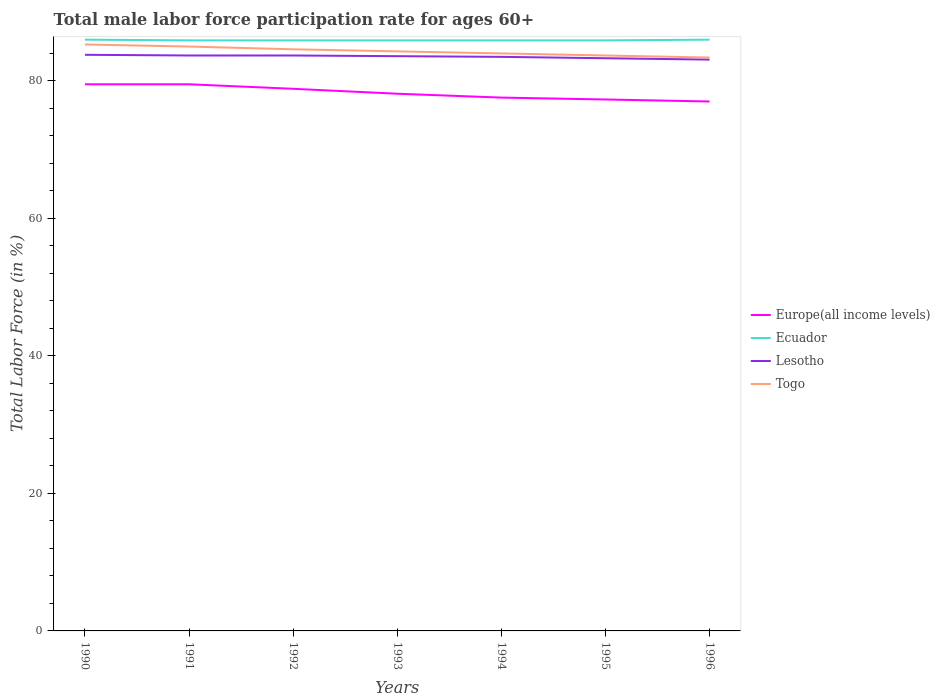Does the line corresponding to Europe(all income levels) intersect with the line corresponding to Lesotho?
Your response must be concise. No. Is the number of lines equal to the number of legend labels?
Keep it short and to the point. Yes. Across all years, what is the maximum male labor force participation rate in Lesotho?
Give a very brief answer. 83.1. What is the total male labor force participation rate in Europe(all income levels) in the graph?
Provide a succinct answer. 2.21. What is the difference between the highest and the second highest male labor force participation rate in Europe(all income levels)?
Provide a succinct answer. 2.5. What is the difference between the highest and the lowest male labor force participation rate in Europe(all income levels)?
Make the answer very short. 3. How many lines are there?
Offer a very short reply. 4. How many years are there in the graph?
Provide a succinct answer. 7. What is the difference between two consecutive major ticks on the Y-axis?
Provide a short and direct response. 20. Does the graph contain any zero values?
Offer a terse response. No. How many legend labels are there?
Give a very brief answer. 4. What is the title of the graph?
Provide a short and direct response. Total male labor force participation rate for ages 60+. Does "Qatar" appear as one of the legend labels in the graph?
Your answer should be very brief. No. What is the label or title of the X-axis?
Keep it short and to the point. Years. What is the label or title of the Y-axis?
Your answer should be compact. Total Labor Force (in %). What is the Total Labor Force (in %) in Europe(all income levels) in 1990?
Your response must be concise. 79.51. What is the Total Labor Force (in %) in Lesotho in 1990?
Ensure brevity in your answer.  83.8. What is the Total Labor Force (in %) in Togo in 1990?
Make the answer very short. 85.3. What is the Total Labor Force (in %) of Europe(all income levels) in 1991?
Give a very brief answer. 79.51. What is the Total Labor Force (in %) in Ecuador in 1991?
Provide a short and direct response. 85.9. What is the Total Labor Force (in %) of Lesotho in 1991?
Offer a very short reply. 83.7. What is the Total Labor Force (in %) in Europe(all income levels) in 1992?
Give a very brief answer. 78.85. What is the Total Labor Force (in %) of Ecuador in 1992?
Offer a very short reply. 85.9. What is the Total Labor Force (in %) of Lesotho in 1992?
Your answer should be compact. 83.7. What is the Total Labor Force (in %) in Togo in 1992?
Offer a very short reply. 84.6. What is the Total Labor Force (in %) in Europe(all income levels) in 1993?
Keep it short and to the point. 78.14. What is the Total Labor Force (in %) of Ecuador in 1993?
Your answer should be compact. 85.9. What is the Total Labor Force (in %) in Lesotho in 1993?
Your answer should be compact. 83.6. What is the Total Labor Force (in %) in Togo in 1993?
Ensure brevity in your answer.  84.3. What is the Total Labor Force (in %) of Europe(all income levels) in 1994?
Give a very brief answer. 77.57. What is the Total Labor Force (in %) of Ecuador in 1994?
Give a very brief answer. 85.9. What is the Total Labor Force (in %) in Lesotho in 1994?
Provide a succinct answer. 83.5. What is the Total Labor Force (in %) of Togo in 1994?
Your answer should be compact. 84. What is the Total Labor Force (in %) in Europe(all income levels) in 1995?
Your answer should be very brief. 77.3. What is the Total Labor Force (in %) in Ecuador in 1995?
Your answer should be compact. 85.9. What is the Total Labor Force (in %) in Lesotho in 1995?
Ensure brevity in your answer.  83.3. What is the Total Labor Force (in %) of Togo in 1995?
Make the answer very short. 83.7. What is the Total Labor Force (in %) in Europe(all income levels) in 1996?
Offer a terse response. 77.01. What is the Total Labor Force (in %) of Ecuador in 1996?
Offer a terse response. 86. What is the Total Labor Force (in %) in Lesotho in 1996?
Provide a succinct answer. 83.1. What is the Total Labor Force (in %) in Togo in 1996?
Offer a very short reply. 83.4. Across all years, what is the maximum Total Labor Force (in %) in Europe(all income levels)?
Your answer should be very brief. 79.51. Across all years, what is the maximum Total Labor Force (in %) of Lesotho?
Give a very brief answer. 83.8. Across all years, what is the maximum Total Labor Force (in %) in Togo?
Provide a succinct answer. 85.3. Across all years, what is the minimum Total Labor Force (in %) of Europe(all income levels)?
Offer a terse response. 77.01. Across all years, what is the minimum Total Labor Force (in %) in Ecuador?
Give a very brief answer. 85.9. Across all years, what is the minimum Total Labor Force (in %) in Lesotho?
Offer a very short reply. 83.1. Across all years, what is the minimum Total Labor Force (in %) in Togo?
Your response must be concise. 83.4. What is the total Total Labor Force (in %) in Europe(all income levels) in the graph?
Give a very brief answer. 547.9. What is the total Total Labor Force (in %) in Ecuador in the graph?
Provide a succinct answer. 601.5. What is the total Total Labor Force (in %) of Lesotho in the graph?
Keep it short and to the point. 584.7. What is the total Total Labor Force (in %) in Togo in the graph?
Make the answer very short. 590.3. What is the difference between the Total Labor Force (in %) of Europe(all income levels) in 1990 and that in 1991?
Your answer should be compact. 0. What is the difference between the Total Labor Force (in %) in Lesotho in 1990 and that in 1991?
Give a very brief answer. 0.1. What is the difference between the Total Labor Force (in %) in Europe(all income levels) in 1990 and that in 1992?
Give a very brief answer. 0.66. What is the difference between the Total Labor Force (in %) in Ecuador in 1990 and that in 1992?
Provide a short and direct response. 0.1. What is the difference between the Total Labor Force (in %) in Lesotho in 1990 and that in 1992?
Your answer should be very brief. 0.1. What is the difference between the Total Labor Force (in %) in Europe(all income levels) in 1990 and that in 1993?
Your response must be concise. 1.37. What is the difference between the Total Labor Force (in %) of Ecuador in 1990 and that in 1993?
Ensure brevity in your answer.  0.1. What is the difference between the Total Labor Force (in %) in Lesotho in 1990 and that in 1993?
Offer a terse response. 0.2. What is the difference between the Total Labor Force (in %) in Europe(all income levels) in 1990 and that in 1994?
Provide a short and direct response. 1.94. What is the difference between the Total Labor Force (in %) of Ecuador in 1990 and that in 1994?
Your answer should be very brief. 0.1. What is the difference between the Total Labor Force (in %) of Lesotho in 1990 and that in 1994?
Offer a terse response. 0.3. What is the difference between the Total Labor Force (in %) in Europe(all income levels) in 1990 and that in 1995?
Your response must be concise. 2.21. What is the difference between the Total Labor Force (in %) in Europe(all income levels) in 1990 and that in 1996?
Provide a succinct answer. 2.5. What is the difference between the Total Labor Force (in %) of Ecuador in 1990 and that in 1996?
Offer a very short reply. 0. What is the difference between the Total Labor Force (in %) of Togo in 1990 and that in 1996?
Offer a very short reply. 1.9. What is the difference between the Total Labor Force (in %) in Europe(all income levels) in 1991 and that in 1992?
Offer a terse response. 0.65. What is the difference between the Total Labor Force (in %) of Europe(all income levels) in 1991 and that in 1993?
Give a very brief answer. 1.37. What is the difference between the Total Labor Force (in %) of Ecuador in 1991 and that in 1993?
Your answer should be compact. 0. What is the difference between the Total Labor Force (in %) in Europe(all income levels) in 1991 and that in 1994?
Keep it short and to the point. 1.94. What is the difference between the Total Labor Force (in %) in Lesotho in 1991 and that in 1994?
Provide a succinct answer. 0.2. What is the difference between the Total Labor Force (in %) in Europe(all income levels) in 1991 and that in 1995?
Provide a short and direct response. 2.21. What is the difference between the Total Labor Force (in %) of Europe(all income levels) in 1991 and that in 1996?
Your answer should be very brief. 2.5. What is the difference between the Total Labor Force (in %) in Europe(all income levels) in 1992 and that in 1993?
Provide a succinct answer. 0.72. What is the difference between the Total Labor Force (in %) of Togo in 1992 and that in 1993?
Give a very brief answer. 0.3. What is the difference between the Total Labor Force (in %) in Europe(all income levels) in 1992 and that in 1994?
Ensure brevity in your answer.  1.28. What is the difference between the Total Labor Force (in %) of Lesotho in 1992 and that in 1994?
Give a very brief answer. 0.2. What is the difference between the Total Labor Force (in %) of Europe(all income levels) in 1992 and that in 1995?
Your answer should be compact. 1.56. What is the difference between the Total Labor Force (in %) in Ecuador in 1992 and that in 1995?
Provide a succinct answer. 0. What is the difference between the Total Labor Force (in %) in Lesotho in 1992 and that in 1995?
Provide a succinct answer. 0.4. What is the difference between the Total Labor Force (in %) in Europe(all income levels) in 1992 and that in 1996?
Your response must be concise. 1.85. What is the difference between the Total Labor Force (in %) of Lesotho in 1992 and that in 1996?
Ensure brevity in your answer.  0.6. What is the difference between the Total Labor Force (in %) in Togo in 1992 and that in 1996?
Your answer should be compact. 1.2. What is the difference between the Total Labor Force (in %) in Europe(all income levels) in 1993 and that in 1994?
Offer a very short reply. 0.57. What is the difference between the Total Labor Force (in %) in Lesotho in 1993 and that in 1994?
Make the answer very short. 0.1. What is the difference between the Total Labor Force (in %) of Togo in 1993 and that in 1994?
Your answer should be very brief. 0.3. What is the difference between the Total Labor Force (in %) in Europe(all income levels) in 1993 and that in 1995?
Ensure brevity in your answer.  0.84. What is the difference between the Total Labor Force (in %) of Lesotho in 1993 and that in 1995?
Provide a short and direct response. 0.3. What is the difference between the Total Labor Force (in %) of Europe(all income levels) in 1993 and that in 1996?
Keep it short and to the point. 1.13. What is the difference between the Total Labor Force (in %) in Togo in 1993 and that in 1996?
Provide a short and direct response. 0.9. What is the difference between the Total Labor Force (in %) in Europe(all income levels) in 1994 and that in 1995?
Make the answer very short. 0.28. What is the difference between the Total Labor Force (in %) in Togo in 1994 and that in 1995?
Your answer should be very brief. 0.3. What is the difference between the Total Labor Force (in %) of Europe(all income levels) in 1994 and that in 1996?
Your response must be concise. 0.56. What is the difference between the Total Labor Force (in %) in Lesotho in 1994 and that in 1996?
Keep it short and to the point. 0.4. What is the difference between the Total Labor Force (in %) of Europe(all income levels) in 1995 and that in 1996?
Give a very brief answer. 0.29. What is the difference between the Total Labor Force (in %) of Ecuador in 1995 and that in 1996?
Provide a short and direct response. -0.1. What is the difference between the Total Labor Force (in %) of Lesotho in 1995 and that in 1996?
Your response must be concise. 0.2. What is the difference between the Total Labor Force (in %) in Europe(all income levels) in 1990 and the Total Labor Force (in %) in Ecuador in 1991?
Ensure brevity in your answer.  -6.39. What is the difference between the Total Labor Force (in %) of Europe(all income levels) in 1990 and the Total Labor Force (in %) of Lesotho in 1991?
Your answer should be very brief. -4.19. What is the difference between the Total Labor Force (in %) of Europe(all income levels) in 1990 and the Total Labor Force (in %) of Togo in 1991?
Offer a terse response. -5.49. What is the difference between the Total Labor Force (in %) in Lesotho in 1990 and the Total Labor Force (in %) in Togo in 1991?
Offer a very short reply. -1.2. What is the difference between the Total Labor Force (in %) in Europe(all income levels) in 1990 and the Total Labor Force (in %) in Ecuador in 1992?
Offer a very short reply. -6.39. What is the difference between the Total Labor Force (in %) in Europe(all income levels) in 1990 and the Total Labor Force (in %) in Lesotho in 1992?
Offer a terse response. -4.19. What is the difference between the Total Labor Force (in %) in Europe(all income levels) in 1990 and the Total Labor Force (in %) in Togo in 1992?
Provide a short and direct response. -5.09. What is the difference between the Total Labor Force (in %) of Ecuador in 1990 and the Total Labor Force (in %) of Lesotho in 1992?
Your answer should be very brief. 2.3. What is the difference between the Total Labor Force (in %) in Ecuador in 1990 and the Total Labor Force (in %) in Togo in 1992?
Keep it short and to the point. 1.4. What is the difference between the Total Labor Force (in %) in Europe(all income levels) in 1990 and the Total Labor Force (in %) in Ecuador in 1993?
Keep it short and to the point. -6.39. What is the difference between the Total Labor Force (in %) of Europe(all income levels) in 1990 and the Total Labor Force (in %) of Lesotho in 1993?
Offer a terse response. -4.09. What is the difference between the Total Labor Force (in %) of Europe(all income levels) in 1990 and the Total Labor Force (in %) of Togo in 1993?
Your answer should be very brief. -4.79. What is the difference between the Total Labor Force (in %) of Ecuador in 1990 and the Total Labor Force (in %) of Lesotho in 1993?
Give a very brief answer. 2.4. What is the difference between the Total Labor Force (in %) in Europe(all income levels) in 1990 and the Total Labor Force (in %) in Ecuador in 1994?
Keep it short and to the point. -6.39. What is the difference between the Total Labor Force (in %) of Europe(all income levels) in 1990 and the Total Labor Force (in %) of Lesotho in 1994?
Your answer should be very brief. -3.99. What is the difference between the Total Labor Force (in %) in Europe(all income levels) in 1990 and the Total Labor Force (in %) in Togo in 1994?
Make the answer very short. -4.49. What is the difference between the Total Labor Force (in %) of Ecuador in 1990 and the Total Labor Force (in %) of Togo in 1994?
Keep it short and to the point. 2. What is the difference between the Total Labor Force (in %) in Lesotho in 1990 and the Total Labor Force (in %) in Togo in 1994?
Offer a terse response. -0.2. What is the difference between the Total Labor Force (in %) in Europe(all income levels) in 1990 and the Total Labor Force (in %) in Ecuador in 1995?
Provide a succinct answer. -6.39. What is the difference between the Total Labor Force (in %) of Europe(all income levels) in 1990 and the Total Labor Force (in %) of Lesotho in 1995?
Keep it short and to the point. -3.79. What is the difference between the Total Labor Force (in %) in Europe(all income levels) in 1990 and the Total Labor Force (in %) in Togo in 1995?
Ensure brevity in your answer.  -4.19. What is the difference between the Total Labor Force (in %) in Ecuador in 1990 and the Total Labor Force (in %) in Lesotho in 1995?
Your response must be concise. 2.7. What is the difference between the Total Labor Force (in %) of Lesotho in 1990 and the Total Labor Force (in %) of Togo in 1995?
Your answer should be compact. 0.1. What is the difference between the Total Labor Force (in %) in Europe(all income levels) in 1990 and the Total Labor Force (in %) in Ecuador in 1996?
Your answer should be very brief. -6.49. What is the difference between the Total Labor Force (in %) in Europe(all income levels) in 1990 and the Total Labor Force (in %) in Lesotho in 1996?
Your answer should be compact. -3.59. What is the difference between the Total Labor Force (in %) of Europe(all income levels) in 1990 and the Total Labor Force (in %) of Togo in 1996?
Ensure brevity in your answer.  -3.89. What is the difference between the Total Labor Force (in %) of Lesotho in 1990 and the Total Labor Force (in %) of Togo in 1996?
Your response must be concise. 0.4. What is the difference between the Total Labor Force (in %) in Europe(all income levels) in 1991 and the Total Labor Force (in %) in Ecuador in 1992?
Make the answer very short. -6.39. What is the difference between the Total Labor Force (in %) of Europe(all income levels) in 1991 and the Total Labor Force (in %) of Lesotho in 1992?
Provide a short and direct response. -4.19. What is the difference between the Total Labor Force (in %) in Europe(all income levels) in 1991 and the Total Labor Force (in %) in Togo in 1992?
Your answer should be very brief. -5.09. What is the difference between the Total Labor Force (in %) in Ecuador in 1991 and the Total Labor Force (in %) in Lesotho in 1992?
Keep it short and to the point. 2.2. What is the difference between the Total Labor Force (in %) of Ecuador in 1991 and the Total Labor Force (in %) of Togo in 1992?
Your response must be concise. 1.3. What is the difference between the Total Labor Force (in %) in Europe(all income levels) in 1991 and the Total Labor Force (in %) in Ecuador in 1993?
Keep it short and to the point. -6.39. What is the difference between the Total Labor Force (in %) of Europe(all income levels) in 1991 and the Total Labor Force (in %) of Lesotho in 1993?
Give a very brief answer. -4.09. What is the difference between the Total Labor Force (in %) of Europe(all income levels) in 1991 and the Total Labor Force (in %) of Togo in 1993?
Keep it short and to the point. -4.79. What is the difference between the Total Labor Force (in %) in Ecuador in 1991 and the Total Labor Force (in %) in Lesotho in 1993?
Provide a short and direct response. 2.3. What is the difference between the Total Labor Force (in %) in Lesotho in 1991 and the Total Labor Force (in %) in Togo in 1993?
Ensure brevity in your answer.  -0.6. What is the difference between the Total Labor Force (in %) of Europe(all income levels) in 1991 and the Total Labor Force (in %) of Ecuador in 1994?
Make the answer very short. -6.39. What is the difference between the Total Labor Force (in %) in Europe(all income levels) in 1991 and the Total Labor Force (in %) in Lesotho in 1994?
Give a very brief answer. -3.99. What is the difference between the Total Labor Force (in %) of Europe(all income levels) in 1991 and the Total Labor Force (in %) of Togo in 1994?
Your answer should be very brief. -4.49. What is the difference between the Total Labor Force (in %) of Lesotho in 1991 and the Total Labor Force (in %) of Togo in 1994?
Give a very brief answer. -0.3. What is the difference between the Total Labor Force (in %) in Europe(all income levels) in 1991 and the Total Labor Force (in %) in Ecuador in 1995?
Ensure brevity in your answer.  -6.39. What is the difference between the Total Labor Force (in %) in Europe(all income levels) in 1991 and the Total Labor Force (in %) in Lesotho in 1995?
Give a very brief answer. -3.79. What is the difference between the Total Labor Force (in %) of Europe(all income levels) in 1991 and the Total Labor Force (in %) of Togo in 1995?
Provide a succinct answer. -4.19. What is the difference between the Total Labor Force (in %) of Ecuador in 1991 and the Total Labor Force (in %) of Togo in 1995?
Make the answer very short. 2.2. What is the difference between the Total Labor Force (in %) in Europe(all income levels) in 1991 and the Total Labor Force (in %) in Ecuador in 1996?
Your response must be concise. -6.49. What is the difference between the Total Labor Force (in %) in Europe(all income levels) in 1991 and the Total Labor Force (in %) in Lesotho in 1996?
Give a very brief answer. -3.59. What is the difference between the Total Labor Force (in %) of Europe(all income levels) in 1991 and the Total Labor Force (in %) of Togo in 1996?
Provide a short and direct response. -3.89. What is the difference between the Total Labor Force (in %) in Europe(all income levels) in 1992 and the Total Labor Force (in %) in Ecuador in 1993?
Your answer should be very brief. -7.05. What is the difference between the Total Labor Force (in %) of Europe(all income levels) in 1992 and the Total Labor Force (in %) of Lesotho in 1993?
Ensure brevity in your answer.  -4.75. What is the difference between the Total Labor Force (in %) in Europe(all income levels) in 1992 and the Total Labor Force (in %) in Togo in 1993?
Your response must be concise. -5.45. What is the difference between the Total Labor Force (in %) in Ecuador in 1992 and the Total Labor Force (in %) in Lesotho in 1993?
Provide a succinct answer. 2.3. What is the difference between the Total Labor Force (in %) in Ecuador in 1992 and the Total Labor Force (in %) in Togo in 1993?
Your answer should be compact. 1.6. What is the difference between the Total Labor Force (in %) of Europe(all income levels) in 1992 and the Total Labor Force (in %) of Ecuador in 1994?
Your response must be concise. -7.05. What is the difference between the Total Labor Force (in %) in Europe(all income levels) in 1992 and the Total Labor Force (in %) in Lesotho in 1994?
Your response must be concise. -4.65. What is the difference between the Total Labor Force (in %) of Europe(all income levels) in 1992 and the Total Labor Force (in %) of Togo in 1994?
Make the answer very short. -5.15. What is the difference between the Total Labor Force (in %) of Ecuador in 1992 and the Total Labor Force (in %) of Lesotho in 1994?
Your answer should be compact. 2.4. What is the difference between the Total Labor Force (in %) of Lesotho in 1992 and the Total Labor Force (in %) of Togo in 1994?
Give a very brief answer. -0.3. What is the difference between the Total Labor Force (in %) in Europe(all income levels) in 1992 and the Total Labor Force (in %) in Ecuador in 1995?
Your response must be concise. -7.05. What is the difference between the Total Labor Force (in %) of Europe(all income levels) in 1992 and the Total Labor Force (in %) of Lesotho in 1995?
Provide a short and direct response. -4.45. What is the difference between the Total Labor Force (in %) of Europe(all income levels) in 1992 and the Total Labor Force (in %) of Togo in 1995?
Give a very brief answer. -4.85. What is the difference between the Total Labor Force (in %) of Ecuador in 1992 and the Total Labor Force (in %) of Lesotho in 1995?
Keep it short and to the point. 2.6. What is the difference between the Total Labor Force (in %) of Lesotho in 1992 and the Total Labor Force (in %) of Togo in 1995?
Give a very brief answer. 0. What is the difference between the Total Labor Force (in %) of Europe(all income levels) in 1992 and the Total Labor Force (in %) of Ecuador in 1996?
Ensure brevity in your answer.  -7.15. What is the difference between the Total Labor Force (in %) of Europe(all income levels) in 1992 and the Total Labor Force (in %) of Lesotho in 1996?
Offer a very short reply. -4.25. What is the difference between the Total Labor Force (in %) in Europe(all income levels) in 1992 and the Total Labor Force (in %) in Togo in 1996?
Your answer should be compact. -4.55. What is the difference between the Total Labor Force (in %) of Ecuador in 1992 and the Total Labor Force (in %) of Lesotho in 1996?
Offer a terse response. 2.8. What is the difference between the Total Labor Force (in %) of Europe(all income levels) in 1993 and the Total Labor Force (in %) of Ecuador in 1994?
Keep it short and to the point. -7.76. What is the difference between the Total Labor Force (in %) of Europe(all income levels) in 1993 and the Total Labor Force (in %) of Lesotho in 1994?
Provide a succinct answer. -5.36. What is the difference between the Total Labor Force (in %) of Europe(all income levels) in 1993 and the Total Labor Force (in %) of Togo in 1994?
Keep it short and to the point. -5.86. What is the difference between the Total Labor Force (in %) in Ecuador in 1993 and the Total Labor Force (in %) in Togo in 1994?
Provide a succinct answer. 1.9. What is the difference between the Total Labor Force (in %) in Lesotho in 1993 and the Total Labor Force (in %) in Togo in 1994?
Keep it short and to the point. -0.4. What is the difference between the Total Labor Force (in %) of Europe(all income levels) in 1993 and the Total Labor Force (in %) of Ecuador in 1995?
Your answer should be very brief. -7.76. What is the difference between the Total Labor Force (in %) of Europe(all income levels) in 1993 and the Total Labor Force (in %) of Lesotho in 1995?
Your answer should be very brief. -5.16. What is the difference between the Total Labor Force (in %) in Europe(all income levels) in 1993 and the Total Labor Force (in %) in Togo in 1995?
Make the answer very short. -5.56. What is the difference between the Total Labor Force (in %) in Ecuador in 1993 and the Total Labor Force (in %) in Lesotho in 1995?
Offer a terse response. 2.6. What is the difference between the Total Labor Force (in %) of Ecuador in 1993 and the Total Labor Force (in %) of Togo in 1995?
Ensure brevity in your answer.  2.2. What is the difference between the Total Labor Force (in %) in Lesotho in 1993 and the Total Labor Force (in %) in Togo in 1995?
Offer a very short reply. -0.1. What is the difference between the Total Labor Force (in %) in Europe(all income levels) in 1993 and the Total Labor Force (in %) in Ecuador in 1996?
Offer a terse response. -7.86. What is the difference between the Total Labor Force (in %) of Europe(all income levels) in 1993 and the Total Labor Force (in %) of Lesotho in 1996?
Give a very brief answer. -4.96. What is the difference between the Total Labor Force (in %) in Europe(all income levels) in 1993 and the Total Labor Force (in %) in Togo in 1996?
Ensure brevity in your answer.  -5.26. What is the difference between the Total Labor Force (in %) of Ecuador in 1993 and the Total Labor Force (in %) of Lesotho in 1996?
Your response must be concise. 2.8. What is the difference between the Total Labor Force (in %) in Ecuador in 1993 and the Total Labor Force (in %) in Togo in 1996?
Offer a terse response. 2.5. What is the difference between the Total Labor Force (in %) in Europe(all income levels) in 1994 and the Total Labor Force (in %) in Ecuador in 1995?
Provide a short and direct response. -8.33. What is the difference between the Total Labor Force (in %) of Europe(all income levels) in 1994 and the Total Labor Force (in %) of Lesotho in 1995?
Provide a succinct answer. -5.73. What is the difference between the Total Labor Force (in %) of Europe(all income levels) in 1994 and the Total Labor Force (in %) of Togo in 1995?
Offer a very short reply. -6.13. What is the difference between the Total Labor Force (in %) in Ecuador in 1994 and the Total Labor Force (in %) in Togo in 1995?
Make the answer very short. 2.2. What is the difference between the Total Labor Force (in %) of Lesotho in 1994 and the Total Labor Force (in %) of Togo in 1995?
Your answer should be very brief. -0.2. What is the difference between the Total Labor Force (in %) in Europe(all income levels) in 1994 and the Total Labor Force (in %) in Ecuador in 1996?
Give a very brief answer. -8.43. What is the difference between the Total Labor Force (in %) in Europe(all income levels) in 1994 and the Total Labor Force (in %) in Lesotho in 1996?
Provide a short and direct response. -5.53. What is the difference between the Total Labor Force (in %) of Europe(all income levels) in 1994 and the Total Labor Force (in %) of Togo in 1996?
Keep it short and to the point. -5.83. What is the difference between the Total Labor Force (in %) of Ecuador in 1994 and the Total Labor Force (in %) of Lesotho in 1996?
Your answer should be compact. 2.8. What is the difference between the Total Labor Force (in %) of Lesotho in 1994 and the Total Labor Force (in %) of Togo in 1996?
Your response must be concise. 0.1. What is the difference between the Total Labor Force (in %) of Europe(all income levels) in 1995 and the Total Labor Force (in %) of Ecuador in 1996?
Ensure brevity in your answer.  -8.7. What is the difference between the Total Labor Force (in %) of Europe(all income levels) in 1995 and the Total Labor Force (in %) of Lesotho in 1996?
Offer a terse response. -5.8. What is the difference between the Total Labor Force (in %) of Europe(all income levels) in 1995 and the Total Labor Force (in %) of Togo in 1996?
Your answer should be very brief. -6.1. What is the difference between the Total Labor Force (in %) in Lesotho in 1995 and the Total Labor Force (in %) in Togo in 1996?
Your answer should be compact. -0.1. What is the average Total Labor Force (in %) in Europe(all income levels) per year?
Provide a short and direct response. 78.27. What is the average Total Labor Force (in %) of Ecuador per year?
Offer a terse response. 85.93. What is the average Total Labor Force (in %) in Lesotho per year?
Keep it short and to the point. 83.53. What is the average Total Labor Force (in %) in Togo per year?
Your response must be concise. 84.33. In the year 1990, what is the difference between the Total Labor Force (in %) of Europe(all income levels) and Total Labor Force (in %) of Ecuador?
Ensure brevity in your answer.  -6.49. In the year 1990, what is the difference between the Total Labor Force (in %) in Europe(all income levels) and Total Labor Force (in %) in Lesotho?
Your answer should be very brief. -4.29. In the year 1990, what is the difference between the Total Labor Force (in %) of Europe(all income levels) and Total Labor Force (in %) of Togo?
Make the answer very short. -5.79. In the year 1990, what is the difference between the Total Labor Force (in %) of Ecuador and Total Labor Force (in %) of Togo?
Provide a succinct answer. 0.7. In the year 1990, what is the difference between the Total Labor Force (in %) of Lesotho and Total Labor Force (in %) of Togo?
Offer a terse response. -1.5. In the year 1991, what is the difference between the Total Labor Force (in %) in Europe(all income levels) and Total Labor Force (in %) in Ecuador?
Ensure brevity in your answer.  -6.39. In the year 1991, what is the difference between the Total Labor Force (in %) in Europe(all income levels) and Total Labor Force (in %) in Lesotho?
Provide a short and direct response. -4.19. In the year 1991, what is the difference between the Total Labor Force (in %) in Europe(all income levels) and Total Labor Force (in %) in Togo?
Your answer should be very brief. -5.49. In the year 1991, what is the difference between the Total Labor Force (in %) of Ecuador and Total Labor Force (in %) of Togo?
Ensure brevity in your answer.  0.9. In the year 1991, what is the difference between the Total Labor Force (in %) in Lesotho and Total Labor Force (in %) in Togo?
Provide a succinct answer. -1.3. In the year 1992, what is the difference between the Total Labor Force (in %) of Europe(all income levels) and Total Labor Force (in %) of Ecuador?
Make the answer very short. -7.05. In the year 1992, what is the difference between the Total Labor Force (in %) in Europe(all income levels) and Total Labor Force (in %) in Lesotho?
Your response must be concise. -4.85. In the year 1992, what is the difference between the Total Labor Force (in %) of Europe(all income levels) and Total Labor Force (in %) of Togo?
Make the answer very short. -5.75. In the year 1992, what is the difference between the Total Labor Force (in %) of Ecuador and Total Labor Force (in %) of Lesotho?
Your answer should be very brief. 2.2. In the year 1992, what is the difference between the Total Labor Force (in %) of Ecuador and Total Labor Force (in %) of Togo?
Provide a succinct answer. 1.3. In the year 1992, what is the difference between the Total Labor Force (in %) of Lesotho and Total Labor Force (in %) of Togo?
Offer a very short reply. -0.9. In the year 1993, what is the difference between the Total Labor Force (in %) in Europe(all income levels) and Total Labor Force (in %) in Ecuador?
Make the answer very short. -7.76. In the year 1993, what is the difference between the Total Labor Force (in %) of Europe(all income levels) and Total Labor Force (in %) of Lesotho?
Keep it short and to the point. -5.46. In the year 1993, what is the difference between the Total Labor Force (in %) of Europe(all income levels) and Total Labor Force (in %) of Togo?
Your answer should be compact. -6.16. In the year 1993, what is the difference between the Total Labor Force (in %) of Ecuador and Total Labor Force (in %) of Lesotho?
Keep it short and to the point. 2.3. In the year 1993, what is the difference between the Total Labor Force (in %) in Lesotho and Total Labor Force (in %) in Togo?
Your answer should be very brief. -0.7. In the year 1994, what is the difference between the Total Labor Force (in %) in Europe(all income levels) and Total Labor Force (in %) in Ecuador?
Provide a succinct answer. -8.33. In the year 1994, what is the difference between the Total Labor Force (in %) of Europe(all income levels) and Total Labor Force (in %) of Lesotho?
Ensure brevity in your answer.  -5.93. In the year 1994, what is the difference between the Total Labor Force (in %) in Europe(all income levels) and Total Labor Force (in %) in Togo?
Your response must be concise. -6.43. In the year 1994, what is the difference between the Total Labor Force (in %) of Ecuador and Total Labor Force (in %) of Lesotho?
Ensure brevity in your answer.  2.4. In the year 1995, what is the difference between the Total Labor Force (in %) in Europe(all income levels) and Total Labor Force (in %) in Ecuador?
Your answer should be very brief. -8.6. In the year 1995, what is the difference between the Total Labor Force (in %) in Europe(all income levels) and Total Labor Force (in %) in Lesotho?
Ensure brevity in your answer.  -6. In the year 1995, what is the difference between the Total Labor Force (in %) in Europe(all income levels) and Total Labor Force (in %) in Togo?
Provide a succinct answer. -6.4. In the year 1995, what is the difference between the Total Labor Force (in %) in Ecuador and Total Labor Force (in %) in Togo?
Give a very brief answer. 2.2. In the year 1995, what is the difference between the Total Labor Force (in %) of Lesotho and Total Labor Force (in %) of Togo?
Offer a terse response. -0.4. In the year 1996, what is the difference between the Total Labor Force (in %) of Europe(all income levels) and Total Labor Force (in %) of Ecuador?
Ensure brevity in your answer.  -8.99. In the year 1996, what is the difference between the Total Labor Force (in %) of Europe(all income levels) and Total Labor Force (in %) of Lesotho?
Keep it short and to the point. -6.09. In the year 1996, what is the difference between the Total Labor Force (in %) in Europe(all income levels) and Total Labor Force (in %) in Togo?
Your answer should be very brief. -6.39. In the year 1996, what is the difference between the Total Labor Force (in %) of Ecuador and Total Labor Force (in %) of Lesotho?
Provide a short and direct response. 2.9. In the year 1996, what is the difference between the Total Labor Force (in %) in Ecuador and Total Labor Force (in %) in Togo?
Your answer should be compact. 2.6. What is the ratio of the Total Labor Force (in %) in Togo in 1990 to that in 1991?
Ensure brevity in your answer.  1. What is the ratio of the Total Labor Force (in %) of Europe(all income levels) in 1990 to that in 1992?
Provide a succinct answer. 1.01. What is the ratio of the Total Labor Force (in %) of Ecuador in 1990 to that in 1992?
Your answer should be very brief. 1. What is the ratio of the Total Labor Force (in %) in Togo in 1990 to that in 1992?
Your response must be concise. 1.01. What is the ratio of the Total Labor Force (in %) of Europe(all income levels) in 1990 to that in 1993?
Your answer should be compact. 1.02. What is the ratio of the Total Labor Force (in %) in Togo in 1990 to that in 1993?
Ensure brevity in your answer.  1.01. What is the ratio of the Total Labor Force (in %) of Europe(all income levels) in 1990 to that in 1994?
Offer a terse response. 1.02. What is the ratio of the Total Labor Force (in %) of Lesotho in 1990 to that in 1994?
Your answer should be compact. 1. What is the ratio of the Total Labor Force (in %) in Togo in 1990 to that in 1994?
Make the answer very short. 1.02. What is the ratio of the Total Labor Force (in %) in Europe(all income levels) in 1990 to that in 1995?
Offer a very short reply. 1.03. What is the ratio of the Total Labor Force (in %) of Ecuador in 1990 to that in 1995?
Offer a very short reply. 1. What is the ratio of the Total Labor Force (in %) of Lesotho in 1990 to that in 1995?
Give a very brief answer. 1.01. What is the ratio of the Total Labor Force (in %) of Togo in 1990 to that in 1995?
Offer a very short reply. 1.02. What is the ratio of the Total Labor Force (in %) in Europe(all income levels) in 1990 to that in 1996?
Your response must be concise. 1.03. What is the ratio of the Total Labor Force (in %) in Ecuador in 1990 to that in 1996?
Provide a succinct answer. 1. What is the ratio of the Total Labor Force (in %) of Lesotho in 1990 to that in 1996?
Make the answer very short. 1.01. What is the ratio of the Total Labor Force (in %) of Togo in 1990 to that in 1996?
Your answer should be compact. 1.02. What is the ratio of the Total Labor Force (in %) in Europe(all income levels) in 1991 to that in 1992?
Give a very brief answer. 1.01. What is the ratio of the Total Labor Force (in %) of Togo in 1991 to that in 1992?
Give a very brief answer. 1. What is the ratio of the Total Labor Force (in %) of Europe(all income levels) in 1991 to that in 1993?
Make the answer very short. 1.02. What is the ratio of the Total Labor Force (in %) in Lesotho in 1991 to that in 1993?
Your response must be concise. 1. What is the ratio of the Total Labor Force (in %) in Togo in 1991 to that in 1993?
Keep it short and to the point. 1.01. What is the ratio of the Total Labor Force (in %) in Europe(all income levels) in 1991 to that in 1994?
Offer a very short reply. 1.02. What is the ratio of the Total Labor Force (in %) in Ecuador in 1991 to that in 1994?
Make the answer very short. 1. What is the ratio of the Total Labor Force (in %) of Togo in 1991 to that in 1994?
Provide a short and direct response. 1.01. What is the ratio of the Total Labor Force (in %) of Europe(all income levels) in 1991 to that in 1995?
Provide a short and direct response. 1.03. What is the ratio of the Total Labor Force (in %) in Togo in 1991 to that in 1995?
Offer a terse response. 1.02. What is the ratio of the Total Labor Force (in %) in Europe(all income levels) in 1991 to that in 1996?
Make the answer very short. 1.03. What is the ratio of the Total Labor Force (in %) of Ecuador in 1991 to that in 1996?
Give a very brief answer. 1. What is the ratio of the Total Labor Force (in %) in Lesotho in 1991 to that in 1996?
Offer a very short reply. 1.01. What is the ratio of the Total Labor Force (in %) in Togo in 1991 to that in 1996?
Offer a terse response. 1.02. What is the ratio of the Total Labor Force (in %) of Europe(all income levels) in 1992 to that in 1993?
Offer a terse response. 1.01. What is the ratio of the Total Labor Force (in %) of Ecuador in 1992 to that in 1993?
Make the answer very short. 1. What is the ratio of the Total Labor Force (in %) of Lesotho in 1992 to that in 1993?
Keep it short and to the point. 1. What is the ratio of the Total Labor Force (in %) of Togo in 1992 to that in 1993?
Ensure brevity in your answer.  1. What is the ratio of the Total Labor Force (in %) in Europe(all income levels) in 1992 to that in 1994?
Provide a succinct answer. 1.02. What is the ratio of the Total Labor Force (in %) of Ecuador in 1992 to that in 1994?
Give a very brief answer. 1. What is the ratio of the Total Labor Force (in %) of Lesotho in 1992 to that in 1994?
Provide a succinct answer. 1. What is the ratio of the Total Labor Force (in %) in Togo in 1992 to that in 1994?
Offer a terse response. 1.01. What is the ratio of the Total Labor Force (in %) of Europe(all income levels) in 1992 to that in 1995?
Your answer should be compact. 1.02. What is the ratio of the Total Labor Force (in %) in Ecuador in 1992 to that in 1995?
Ensure brevity in your answer.  1. What is the ratio of the Total Labor Force (in %) in Lesotho in 1992 to that in 1995?
Your answer should be very brief. 1. What is the ratio of the Total Labor Force (in %) in Togo in 1992 to that in 1995?
Your answer should be compact. 1.01. What is the ratio of the Total Labor Force (in %) of Europe(all income levels) in 1992 to that in 1996?
Your response must be concise. 1.02. What is the ratio of the Total Labor Force (in %) in Ecuador in 1992 to that in 1996?
Offer a terse response. 1. What is the ratio of the Total Labor Force (in %) of Lesotho in 1992 to that in 1996?
Your answer should be very brief. 1.01. What is the ratio of the Total Labor Force (in %) of Togo in 1992 to that in 1996?
Your response must be concise. 1.01. What is the ratio of the Total Labor Force (in %) of Europe(all income levels) in 1993 to that in 1994?
Provide a short and direct response. 1.01. What is the ratio of the Total Labor Force (in %) in Ecuador in 1993 to that in 1994?
Your answer should be very brief. 1. What is the ratio of the Total Labor Force (in %) in Europe(all income levels) in 1993 to that in 1995?
Offer a very short reply. 1.01. What is the ratio of the Total Labor Force (in %) of Lesotho in 1993 to that in 1995?
Provide a succinct answer. 1. What is the ratio of the Total Labor Force (in %) of Europe(all income levels) in 1993 to that in 1996?
Make the answer very short. 1.01. What is the ratio of the Total Labor Force (in %) in Ecuador in 1993 to that in 1996?
Your answer should be very brief. 1. What is the ratio of the Total Labor Force (in %) in Lesotho in 1993 to that in 1996?
Your response must be concise. 1.01. What is the ratio of the Total Labor Force (in %) of Togo in 1993 to that in 1996?
Make the answer very short. 1.01. What is the ratio of the Total Labor Force (in %) of Ecuador in 1994 to that in 1995?
Offer a very short reply. 1. What is the ratio of the Total Labor Force (in %) of Togo in 1994 to that in 1995?
Offer a very short reply. 1. What is the ratio of the Total Labor Force (in %) in Europe(all income levels) in 1994 to that in 1996?
Keep it short and to the point. 1.01. What is the ratio of the Total Labor Force (in %) of Ecuador in 1994 to that in 1996?
Your answer should be compact. 1. What is the ratio of the Total Labor Force (in %) of Europe(all income levels) in 1995 to that in 1996?
Give a very brief answer. 1. What is the ratio of the Total Labor Force (in %) in Ecuador in 1995 to that in 1996?
Ensure brevity in your answer.  1. What is the ratio of the Total Labor Force (in %) of Togo in 1995 to that in 1996?
Provide a short and direct response. 1. What is the difference between the highest and the second highest Total Labor Force (in %) in Europe(all income levels)?
Keep it short and to the point. 0. What is the difference between the highest and the second highest Total Labor Force (in %) of Ecuador?
Offer a terse response. 0. What is the difference between the highest and the lowest Total Labor Force (in %) in Europe(all income levels)?
Provide a short and direct response. 2.5. What is the difference between the highest and the lowest Total Labor Force (in %) in Ecuador?
Offer a very short reply. 0.1. 